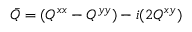<formula> <loc_0><loc_0><loc_500><loc_500>\bar { Q } = ( Q ^ { x x } - Q ^ { y y } ) - i ( 2 Q ^ { x y } )</formula> 